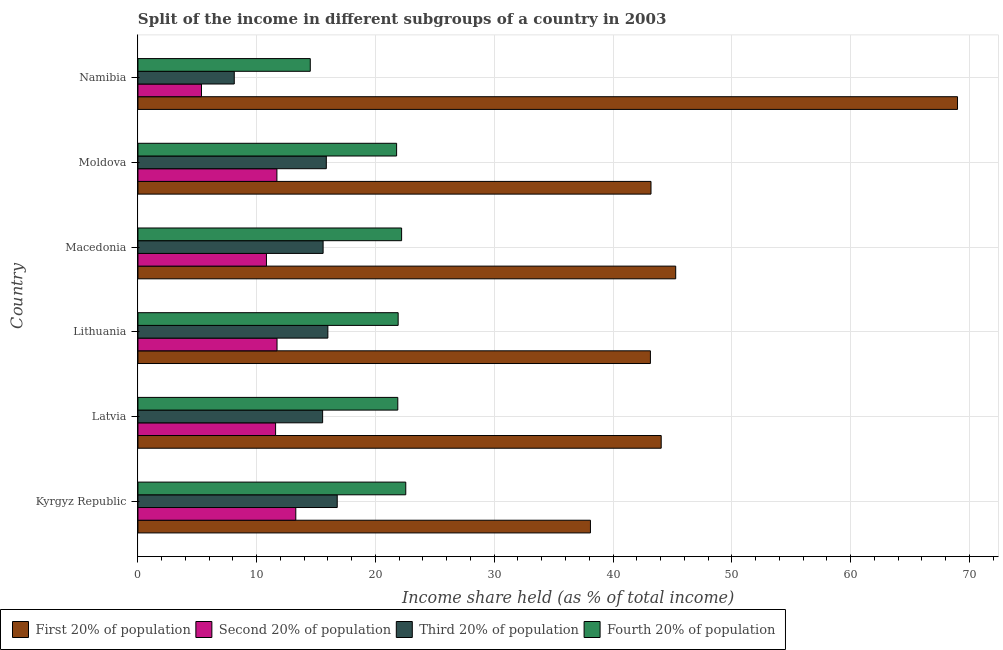How many groups of bars are there?
Provide a short and direct response. 6. What is the label of the 2nd group of bars from the top?
Your response must be concise. Moldova. What is the share of the income held by fourth 20% of the population in Namibia?
Make the answer very short. 14.51. Across all countries, what is the maximum share of the income held by fourth 20% of the population?
Offer a very short reply. 22.55. Across all countries, what is the minimum share of the income held by fourth 20% of the population?
Your answer should be compact. 14.51. In which country was the share of the income held by second 20% of the population maximum?
Make the answer very short. Kyrgyz Republic. In which country was the share of the income held by first 20% of the population minimum?
Give a very brief answer. Kyrgyz Republic. What is the total share of the income held by third 20% of the population in the graph?
Your response must be concise. 87.88. What is the difference between the share of the income held by second 20% of the population in Macedonia and that in Moldova?
Ensure brevity in your answer.  -0.88. What is the difference between the share of the income held by third 20% of the population in Kyrgyz Republic and the share of the income held by second 20% of the population in Lithuania?
Your answer should be compact. 5.07. What is the average share of the income held by first 20% of the population per country?
Offer a very short reply. 47.13. What is the difference between the share of the income held by third 20% of the population and share of the income held by fourth 20% of the population in Macedonia?
Give a very brief answer. -6.61. What is the ratio of the share of the income held by first 20% of the population in Kyrgyz Republic to that in Lithuania?
Make the answer very short. 0.88. What is the difference between the highest and the second highest share of the income held by first 20% of the population?
Provide a short and direct response. 23.73. What is the difference between the highest and the lowest share of the income held by first 20% of the population?
Your answer should be very brief. 30.91. Is the sum of the share of the income held by fourth 20% of the population in Latvia and Lithuania greater than the maximum share of the income held by third 20% of the population across all countries?
Your answer should be very brief. Yes. What does the 3rd bar from the top in Moldova represents?
Your answer should be very brief. Second 20% of population. What does the 3rd bar from the bottom in Namibia represents?
Provide a short and direct response. Third 20% of population. Is it the case that in every country, the sum of the share of the income held by first 20% of the population and share of the income held by second 20% of the population is greater than the share of the income held by third 20% of the population?
Ensure brevity in your answer.  Yes. How many bars are there?
Your answer should be very brief. 24. Are all the bars in the graph horizontal?
Your response must be concise. Yes. What is the difference between two consecutive major ticks on the X-axis?
Provide a succinct answer. 10. Are the values on the major ticks of X-axis written in scientific E-notation?
Provide a succinct answer. No. How many legend labels are there?
Your answer should be compact. 4. How are the legend labels stacked?
Give a very brief answer. Horizontal. What is the title of the graph?
Provide a short and direct response. Split of the income in different subgroups of a country in 2003. Does "First 20% of population" appear as one of the legend labels in the graph?
Your response must be concise. Yes. What is the label or title of the X-axis?
Provide a short and direct response. Income share held (as % of total income). What is the label or title of the Y-axis?
Keep it short and to the point. Country. What is the Income share held (as % of total income) in First 20% of population in Kyrgyz Republic?
Offer a terse response. 38.1. What is the Income share held (as % of total income) of Second 20% of population in Kyrgyz Republic?
Make the answer very short. 13.29. What is the Income share held (as % of total income) of Third 20% of population in Kyrgyz Republic?
Keep it short and to the point. 16.78. What is the Income share held (as % of total income) of Fourth 20% of population in Kyrgyz Republic?
Keep it short and to the point. 22.55. What is the Income share held (as % of total income) in First 20% of population in Latvia?
Your response must be concise. 44.06. What is the Income share held (as % of total income) of Second 20% of population in Latvia?
Ensure brevity in your answer.  11.59. What is the Income share held (as % of total income) in Third 20% of population in Latvia?
Offer a terse response. 15.55. What is the Income share held (as % of total income) of Fourth 20% of population in Latvia?
Ensure brevity in your answer.  21.88. What is the Income share held (as % of total income) in First 20% of population in Lithuania?
Offer a very short reply. 43.15. What is the Income share held (as % of total income) in Second 20% of population in Lithuania?
Offer a terse response. 11.71. What is the Income share held (as % of total income) of Third 20% of population in Lithuania?
Give a very brief answer. 15.99. What is the Income share held (as % of total income) of Fourth 20% of population in Lithuania?
Provide a succinct answer. 21.91. What is the Income share held (as % of total income) in First 20% of population in Macedonia?
Give a very brief answer. 45.28. What is the Income share held (as % of total income) of Second 20% of population in Macedonia?
Ensure brevity in your answer.  10.82. What is the Income share held (as % of total income) in Third 20% of population in Macedonia?
Your answer should be very brief. 15.59. What is the Income share held (as % of total income) of First 20% of population in Moldova?
Keep it short and to the point. 43.2. What is the Income share held (as % of total income) in Third 20% of population in Moldova?
Provide a short and direct response. 15.86. What is the Income share held (as % of total income) of Fourth 20% of population in Moldova?
Offer a very short reply. 21.78. What is the Income share held (as % of total income) in First 20% of population in Namibia?
Give a very brief answer. 69.01. What is the Income share held (as % of total income) of Second 20% of population in Namibia?
Give a very brief answer. 5.35. What is the Income share held (as % of total income) in Third 20% of population in Namibia?
Your answer should be compact. 8.11. What is the Income share held (as % of total income) in Fourth 20% of population in Namibia?
Your answer should be compact. 14.51. Across all countries, what is the maximum Income share held (as % of total income) in First 20% of population?
Make the answer very short. 69.01. Across all countries, what is the maximum Income share held (as % of total income) in Second 20% of population?
Give a very brief answer. 13.29. Across all countries, what is the maximum Income share held (as % of total income) of Third 20% of population?
Give a very brief answer. 16.78. Across all countries, what is the maximum Income share held (as % of total income) in Fourth 20% of population?
Your response must be concise. 22.55. Across all countries, what is the minimum Income share held (as % of total income) of First 20% of population?
Provide a succinct answer. 38.1. Across all countries, what is the minimum Income share held (as % of total income) of Second 20% of population?
Your answer should be compact. 5.35. Across all countries, what is the minimum Income share held (as % of total income) in Third 20% of population?
Offer a terse response. 8.11. Across all countries, what is the minimum Income share held (as % of total income) in Fourth 20% of population?
Provide a succinct answer. 14.51. What is the total Income share held (as % of total income) of First 20% of population in the graph?
Your answer should be compact. 282.8. What is the total Income share held (as % of total income) in Second 20% of population in the graph?
Your answer should be compact. 64.46. What is the total Income share held (as % of total income) in Third 20% of population in the graph?
Your answer should be very brief. 87.88. What is the total Income share held (as % of total income) of Fourth 20% of population in the graph?
Offer a terse response. 124.83. What is the difference between the Income share held (as % of total income) in First 20% of population in Kyrgyz Republic and that in Latvia?
Offer a very short reply. -5.96. What is the difference between the Income share held (as % of total income) in Second 20% of population in Kyrgyz Republic and that in Latvia?
Offer a terse response. 1.7. What is the difference between the Income share held (as % of total income) of Third 20% of population in Kyrgyz Republic and that in Latvia?
Your answer should be compact. 1.23. What is the difference between the Income share held (as % of total income) in Fourth 20% of population in Kyrgyz Republic and that in Latvia?
Offer a terse response. 0.67. What is the difference between the Income share held (as % of total income) in First 20% of population in Kyrgyz Republic and that in Lithuania?
Provide a short and direct response. -5.05. What is the difference between the Income share held (as % of total income) of Second 20% of population in Kyrgyz Republic and that in Lithuania?
Keep it short and to the point. 1.58. What is the difference between the Income share held (as % of total income) in Third 20% of population in Kyrgyz Republic and that in Lithuania?
Ensure brevity in your answer.  0.79. What is the difference between the Income share held (as % of total income) of Fourth 20% of population in Kyrgyz Republic and that in Lithuania?
Make the answer very short. 0.64. What is the difference between the Income share held (as % of total income) in First 20% of population in Kyrgyz Republic and that in Macedonia?
Provide a short and direct response. -7.18. What is the difference between the Income share held (as % of total income) of Second 20% of population in Kyrgyz Republic and that in Macedonia?
Give a very brief answer. 2.47. What is the difference between the Income share held (as % of total income) in Third 20% of population in Kyrgyz Republic and that in Macedonia?
Keep it short and to the point. 1.19. What is the difference between the Income share held (as % of total income) in First 20% of population in Kyrgyz Republic and that in Moldova?
Provide a short and direct response. -5.1. What is the difference between the Income share held (as % of total income) in Second 20% of population in Kyrgyz Republic and that in Moldova?
Your response must be concise. 1.59. What is the difference between the Income share held (as % of total income) of Third 20% of population in Kyrgyz Republic and that in Moldova?
Keep it short and to the point. 0.92. What is the difference between the Income share held (as % of total income) in Fourth 20% of population in Kyrgyz Republic and that in Moldova?
Ensure brevity in your answer.  0.77. What is the difference between the Income share held (as % of total income) of First 20% of population in Kyrgyz Republic and that in Namibia?
Your response must be concise. -30.91. What is the difference between the Income share held (as % of total income) of Second 20% of population in Kyrgyz Republic and that in Namibia?
Provide a short and direct response. 7.94. What is the difference between the Income share held (as % of total income) in Third 20% of population in Kyrgyz Republic and that in Namibia?
Ensure brevity in your answer.  8.67. What is the difference between the Income share held (as % of total income) of Fourth 20% of population in Kyrgyz Republic and that in Namibia?
Your answer should be very brief. 8.04. What is the difference between the Income share held (as % of total income) of First 20% of population in Latvia and that in Lithuania?
Your answer should be very brief. 0.91. What is the difference between the Income share held (as % of total income) of Second 20% of population in Latvia and that in Lithuania?
Provide a short and direct response. -0.12. What is the difference between the Income share held (as % of total income) of Third 20% of population in Latvia and that in Lithuania?
Your response must be concise. -0.44. What is the difference between the Income share held (as % of total income) of Fourth 20% of population in Latvia and that in Lithuania?
Give a very brief answer. -0.03. What is the difference between the Income share held (as % of total income) of First 20% of population in Latvia and that in Macedonia?
Provide a short and direct response. -1.22. What is the difference between the Income share held (as % of total income) in Second 20% of population in Latvia and that in Macedonia?
Your answer should be very brief. 0.77. What is the difference between the Income share held (as % of total income) of Third 20% of population in Latvia and that in Macedonia?
Your answer should be compact. -0.04. What is the difference between the Income share held (as % of total income) in Fourth 20% of population in Latvia and that in Macedonia?
Keep it short and to the point. -0.32. What is the difference between the Income share held (as % of total income) of First 20% of population in Latvia and that in Moldova?
Your answer should be very brief. 0.86. What is the difference between the Income share held (as % of total income) in Second 20% of population in Latvia and that in Moldova?
Ensure brevity in your answer.  -0.11. What is the difference between the Income share held (as % of total income) of Third 20% of population in Latvia and that in Moldova?
Provide a short and direct response. -0.31. What is the difference between the Income share held (as % of total income) in Fourth 20% of population in Latvia and that in Moldova?
Keep it short and to the point. 0.1. What is the difference between the Income share held (as % of total income) of First 20% of population in Latvia and that in Namibia?
Offer a very short reply. -24.95. What is the difference between the Income share held (as % of total income) of Second 20% of population in Latvia and that in Namibia?
Offer a terse response. 6.24. What is the difference between the Income share held (as % of total income) of Third 20% of population in Latvia and that in Namibia?
Provide a short and direct response. 7.44. What is the difference between the Income share held (as % of total income) of Fourth 20% of population in Latvia and that in Namibia?
Make the answer very short. 7.37. What is the difference between the Income share held (as % of total income) of First 20% of population in Lithuania and that in Macedonia?
Provide a succinct answer. -2.13. What is the difference between the Income share held (as % of total income) of Second 20% of population in Lithuania and that in Macedonia?
Keep it short and to the point. 0.89. What is the difference between the Income share held (as % of total income) of Third 20% of population in Lithuania and that in Macedonia?
Provide a short and direct response. 0.4. What is the difference between the Income share held (as % of total income) in Fourth 20% of population in Lithuania and that in Macedonia?
Provide a succinct answer. -0.29. What is the difference between the Income share held (as % of total income) in First 20% of population in Lithuania and that in Moldova?
Your answer should be very brief. -0.05. What is the difference between the Income share held (as % of total income) of Second 20% of population in Lithuania and that in Moldova?
Provide a short and direct response. 0.01. What is the difference between the Income share held (as % of total income) of Third 20% of population in Lithuania and that in Moldova?
Provide a succinct answer. 0.13. What is the difference between the Income share held (as % of total income) of Fourth 20% of population in Lithuania and that in Moldova?
Your response must be concise. 0.13. What is the difference between the Income share held (as % of total income) of First 20% of population in Lithuania and that in Namibia?
Offer a terse response. -25.86. What is the difference between the Income share held (as % of total income) of Second 20% of population in Lithuania and that in Namibia?
Offer a very short reply. 6.36. What is the difference between the Income share held (as % of total income) in Third 20% of population in Lithuania and that in Namibia?
Provide a succinct answer. 7.88. What is the difference between the Income share held (as % of total income) in First 20% of population in Macedonia and that in Moldova?
Keep it short and to the point. 2.08. What is the difference between the Income share held (as % of total income) in Second 20% of population in Macedonia and that in Moldova?
Ensure brevity in your answer.  -0.88. What is the difference between the Income share held (as % of total income) in Third 20% of population in Macedonia and that in Moldova?
Provide a succinct answer. -0.27. What is the difference between the Income share held (as % of total income) in Fourth 20% of population in Macedonia and that in Moldova?
Your answer should be compact. 0.42. What is the difference between the Income share held (as % of total income) in First 20% of population in Macedonia and that in Namibia?
Ensure brevity in your answer.  -23.73. What is the difference between the Income share held (as % of total income) of Second 20% of population in Macedonia and that in Namibia?
Offer a terse response. 5.47. What is the difference between the Income share held (as % of total income) of Third 20% of population in Macedonia and that in Namibia?
Provide a short and direct response. 7.48. What is the difference between the Income share held (as % of total income) of Fourth 20% of population in Macedonia and that in Namibia?
Give a very brief answer. 7.69. What is the difference between the Income share held (as % of total income) of First 20% of population in Moldova and that in Namibia?
Offer a terse response. -25.81. What is the difference between the Income share held (as % of total income) in Second 20% of population in Moldova and that in Namibia?
Ensure brevity in your answer.  6.35. What is the difference between the Income share held (as % of total income) of Third 20% of population in Moldova and that in Namibia?
Give a very brief answer. 7.75. What is the difference between the Income share held (as % of total income) of Fourth 20% of population in Moldova and that in Namibia?
Give a very brief answer. 7.27. What is the difference between the Income share held (as % of total income) of First 20% of population in Kyrgyz Republic and the Income share held (as % of total income) of Second 20% of population in Latvia?
Make the answer very short. 26.51. What is the difference between the Income share held (as % of total income) in First 20% of population in Kyrgyz Republic and the Income share held (as % of total income) in Third 20% of population in Latvia?
Ensure brevity in your answer.  22.55. What is the difference between the Income share held (as % of total income) of First 20% of population in Kyrgyz Republic and the Income share held (as % of total income) of Fourth 20% of population in Latvia?
Keep it short and to the point. 16.22. What is the difference between the Income share held (as % of total income) in Second 20% of population in Kyrgyz Republic and the Income share held (as % of total income) in Third 20% of population in Latvia?
Your response must be concise. -2.26. What is the difference between the Income share held (as % of total income) in Second 20% of population in Kyrgyz Republic and the Income share held (as % of total income) in Fourth 20% of population in Latvia?
Your response must be concise. -8.59. What is the difference between the Income share held (as % of total income) in First 20% of population in Kyrgyz Republic and the Income share held (as % of total income) in Second 20% of population in Lithuania?
Make the answer very short. 26.39. What is the difference between the Income share held (as % of total income) of First 20% of population in Kyrgyz Republic and the Income share held (as % of total income) of Third 20% of population in Lithuania?
Your answer should be very brief. 22.11. What is the difference between the Income share held (as % of total income) of First 20% of population in Kyrgyz Republic and the Income share held (as % of total income) of Fourth 20% of population in Lithuania?
Offer a very short reply. 16.19. What is the difference between the Income share held (as % of total income) of Second 20% of population in Kyrgyz Republic and the Income share held (as % of total income) of Third 20% of population in Lithuania?
Your answer should be compact. -2.7. What is the difference between the Income share held (as % of total income) of Second 20% of population in Kyrgyz Republic and the Income share held (as % of total income) of Fourth 20% of population in Lithuania?
Provide a succinct answer. -8.62. What is the difference between the Income share held (as % of total income) of Third 20% of population in Kyrgyz Republic and the Income share held (as % of total income) of Fourth 20% of population in Lithuania?
Make the answer very short. -5.13. What is the difference between the Income share held (as % of total income) of First 20% of population in Kyrgyz Republic and the Income share held (as % of total income) of Second 20% of population in Macedonia?
Provide a short and direct response. 27.28. What is the difference between the Income share held (as % of total income) in First 20% of population in Kyrgyz Republic and the Income share held (as % of total income) in Third 20% of population in Macedonia?
Your answer should be compact. 22.51. What is the difference between the Income share held (as % of total income) in Second 20% of population in Kyrgyz Republic and the Income share held (as % of total income) in Fourth 20% of population in Macedonia?
Provide a short and direct response. -8.91. What is the difference between the Income share held (as % of total income) of Third 20% of population in Kyrgyz Republic and the Income share held (as % of total income) of Fourth 20% of population in Macedonia?
Offer a very short reply. -5.42. What is the difference between the Income share held (as % of total income) in First 20% of population in Kyrgyz Republic and the Income share held (as % of total income) in Second 20% of population in Moldova?
Provide a short and direct response. 26.4. What is the difference between the Income share held (as % of total income) in First 20% of population in Kyrgyz Republic and the Income share held (as % of total income) in Third 20% of population in Moldova?
Keep it short and to the point. 22.24. What is the difference between the Income share held (as % of total income) of First 20% of population in Kyrgyz Republic and the Income share held (as % of total income) of Fourth 20% of population in Moldova?
Your answer should be compact. 16.32. What is the difference between the Income share held (as % of total income) in Second 20% of population in Kyrgyz Republic and the Income share held (as % of total income) in Third 20% of population in Moldova?
Keep it short and to the point. -2.57. What is the difference between the Income share held (as % of total income) of Second 20% of population in Kyrgyz Republic and the Income share held (as % of total income) of Fourth 20% of population in Moldova?
Make the answer very short. -8.49. What is the difference between the Income share held (as % of total income) in First 20% of population in Kyrgyz Republic and the Income share held (as % of total income) in Second 20% of population in Namibia?
Provide a short and direct response. 32.75. What is the difference between the Income share held (as % of total income) in First 20% of population in Kyrgyz Republic and the Income share held (as % of total income) in Third 20% of population in Namibia?
Ensure brevity in your answer.  29.99. What is the difference between the Income share held (as % of total income) in First 20% of population in Kyrgyz Republic and the Income share held (as % of total income) in Fourth 20% of population in Namibia?
Ensure brevity in your answer.  23.59. What is the difference between the Income share held (as % of total income) in Second 20% of population in Kyrgyz Republic and the Income share held (as % of total income) in Third 20% of population in Namibia?
Your answer should be compact. 5.18. What is the difference between the Income share held (as % of total income) of Second 20% of population in Kyrgyz Republic and the Income share held (as % of total income) of Fourth 20% of population in Namibia?
Your response must be concise. -1.22. What is the difference between the Income share held (as % of total income) in Third 20% of population in Kyrgyz Republic and the Income share held (as % of total income) in Fourth 20% of population in Namibia?
Your response must be concise. 2.27. What is the difference between the Income share held (as % of total income) of First 20% of population in Latvia and the Income share held (as % of total income) of Second 20% of population in Lithuania?
Offer a very short reply. 32.35. What is the difference between the Income share held (as % of total income) in First 20% of population in Latvia and the Income share held (as % of total income) in Third 20% of population in Lithuania?
Your response must be concise. 28.07. What is the difference between the Income share held (as % of total income) of First 20% of population in Latvia and the Income share held (as % of total income) of Fourth 20% of population in Lithuania?
Provide a short and direct response. 22.15. What is the difference between the Income share held (as % of total income) in Second 20% of population in Latvia and the Income share held (as % of total income) in Third 20% of population in Lithuania?
Provide a short and direct response. -4.4. What is the difference between the Income share held (as % of total income) in Second 20% of population in Latvia and the Income share held (as % of total income) in Fourth 20% of population in Lithuania?
Offer a terse response. -10.32. What is the difference between the Income share held (as % of total income) in Third 20% of population in Latvia and the Income share held (as % of total income) in Fourth 20% of population in Lithuania?
Provide a short and direct response. -6.36. What is the difference between the Income share held (as % of total income) of First 20% of population in Latvia and the Income share held (as % of total income) of Second 20% of population in Macedonia?
Ensure brevity in your answer.  33.24. What is the difference between the Income share held (as % of total income) of First 20% of population in Latvia and the Income share held (as % of total income) of Third 20% of population in Macedonia?
Your answer should be compact. 28.47. What is the difference between the Income share held (as % of total income) in First 20% of population in Latvia and the Income share held (as % of total income) in Fourth 20% of population in Macedonia?
Offer a very short reply. 21.86. What is the difference between the Income share held (as % of total income) in Second 20% of population in Latvia and the Income share held (as % of total income) in Third 20% of population in Macedonia?
Make the answer very short. -4. What is the difference between the Income share held (as % of total income) of Second 20% of population in Latvia and the Income share held (as % of total income) of Fourth 20% of population in Macedonia?
Ensure brevity in your answer.  -10.61. What is the difference between the Income share held (as % of total income) of Third 20% of population in Latvia and the Income share held (as % of total income) of Fourth 20% of population in Macedonia?
Offer a terse response. -6.65. What is the difference between the Income share held (as % of total income) of First 20% of population in Latvia and the Income share held (as % of total income) of Second 20% of population in Moldova?
Your answer should be compact. 32.36. What is the difference between the Income share held (as % of total income) of First 20% of population in Latvia and the Income share held (as % of total income) of Third 20% of population in Moldova?
Ensure brevity in your answer.  28.2. What is the difference between the Income share held (as % of total income) in First 20% of population in Latvia and the Income share held (as % of total income) in Fourth 20% of population in Moldova?
Ensure brevity in your answer.  22.28. What is the difference between the Income share held (as % of total income) in Second 20% of population in Latvia and the Income share held (as % of total income) in Third 20% of population in Moldova?
Ensure brevity in your answer.  -4.27. What is the difference between the Income share held (as % of total income) of Second 20% of population in Latvia and the Income share held (as % of total income) of Fourth 20% of population in Moldova?
Provide a short and direct response. -10.19. What is the difference between the Income share held (as % of total income) of Third 20% of population in Latvia and the Income share held (as % of total income) of Fourth 20% of population in Moldova?
Offer a terse response. -6.23. What is the difference between the Income share held (as % of total income) in First 20% of population in Latvia and the Income share held (as % of total income) in Second 20% of population in Namibia?
Keep it short and to the point. 38.71. What is the difference between the Income share held (as % of total income) in First 20% of population in Latvia and the Income share held (as % of total income) in Third 20% of population in Namibia?
Offer a very short reply. 35.95. What is the difference between the Income share held (as % of total income) in First 20% of population in Latvia and the Income share held (as % of total income) in Fourth 20% of population in Namibia?
Provide a short and direct response. 29.55. What is the difference between the Income share held (as % of total income) in Second 20% of population in Latvia and the Income share held (as % of total income) in Third 20% of population in Namibia?
Offer a very short reply. 3.48. What is the difference between the Income share held (as % of total income) in Second 20% of population in Latvia and the Income share held (as % of total income) in Fourth 20% of population in Namibia?
Offer a terse response. -2.92. What is the difference between the Income share held (as % of total income) in First 20% of population in Lithuania and the Income share held (as % of total income) in Second 20% of population in Macedonia?
Offer a very short reply. 32.33. What is the difference between the Income share held (as % of total income) in First 20% of population in Lithuania and the Income share held (as % of total income) in Third 20% of population in Macedonia?
Make the answer very short. 27.56. What is the difference between the Income share held (as % of total income) of First 20% of population in Lithuania and the Income share held (as % of total income) of Fourth 20% of population in Macedonia?
Your answer should be very brief. 20.95. What is the difference between the Income share held (as % of total income) in Second 20% of population in Lithuania and the Income share held (as % of total income) in Third 20% of population in Macedonia?
Offer a very short reply. -3.88. What is the difference between the Income share held (as % of total income) of Second 20% of population in Lithuania and the Income share held (as % of total income) of Fourth 20% of population in Macedonia?
Provide a short and direct response. -10.49. What is the difference between the Income share held (as % of total income) of Third 20% of population in Lithuania and the Income share held (as % of total income) of Fourth 20% of population in Macedonia?
Your answer should be very brief. -6.21. What is the difference between the Income share held (as % of total income) of First 20% of population in Lithuania and the Income share held (as % of total income) of Second 20% of population in Moldova?
Ensure brevity in your answer.  31.45. What is the difference between the Income share held (as % of total income) in First 20% of population in Lithuania and the Income share held (as % of total income) in Third 20% of population in Moldova?
Your response must be concise. 27.29. What is the difference between the Income share held (as % of total income) of First 20% of population in Lithuania and the Income share held (as % of total income) of Fourth 20% of population in Moldova?
Keep it short and to the point. 21.37. What is the difference between the Income share held (as % of total income) in Second 20% of population in Lithuania and the Income share held (as % of total income) in Third 20% of population in Moldova?
Keep it short and to the point. -4.15. What is the difference between the Income share held (as % of total income) of Second 20% of population in Lithuania and the Income share held (as % of total income) of Fourth 20% of population in Moldova?
Offer a very short reply. -10.07. What is the difference between the Income share held (as % of total income) of Third 20% of population in Lithuania and the Income share held (as % of total income) of Fourth 20% of population in Moldova?
Provide a succinct answer. -5.79. What is the difference between the Income share held (as % of total income) of First 20% of population in Lithuania and the Income share held (as % of total income) of Second 20% of population in Namibia?
Make the answer very short. 37.8. What is the difference between the Income share held (as % of total income) in First 20% of population in Lithuania and the Income share held (as % of total income) in Third 20% of population in Namibia?
Provide a short and direct response. 35.04. What is the difference between the Income share held (as % of total income) of First 20% of population in Lithuania and the Income share held (as % of total income) of Fourth 20% of population in Namibia?
Provide a succinct answer. 28.64. What is the difference between the Income share held (as % of total income) in Third 20% of population in Lithuania and the Income share held (as % of total income) in Fourth 20% of population in Namibia?
Ensure brevity in your answer.  1.48. What is the difference between the Income share held (as % of total income) in First 20% of population in Macedonia and the Income share held (as % of total income) in Second 20% of population in Moldova?
Keep it short and to the point. 33.58. What is the difference between the Income share held (as % of total income) of First 20% of population in Macedonia and the Income share held (as % of total income) of Third 20% of population in Moldova?
Your answer should be compact. 29.42. What is the difference between the Income share held (as % of total income) in First 20% of population in Macedonia and the Income share held (as % of total income) in Fourth 20% of population in Moldova?
Provide a succinct answer. 23.5. What is the difference between the Income share held (as % of total income) of Second 20% of population in Macedonia and the Income share held (as % of total income) of Third 20% of population in Moldova?
Give a very brief answer. -5.04. What is the difference between the Income share held (as % of total income) of Second 20% of population in Macedonia and the Income share held (as % of total income) of Fourth 20% of population in Moldova?
Ensure brevity in your answer.  -10.96. What is the difference between the Income share held (as % of total income) of Third 20% of population in Macedonia and the Income share held (as % of total income) of Fourth 20% of population in Moldova?
Ensure brevity in your answer.  -6.19. What is the difference between the Income share held (as % of total income) of First 20% of population in Macedonia and the Income share held (as % of total income) of Second 20% of population in Namibia?
Keep it short and to the point. 39.93. What is the difference between the Income share held (as % of total income) in First 20% of population in Macedonia and the Income share held (as % of total income) in Third 20% of population in Namibia?
Keep it short and to the point. 37.17. What is the difference between the Income share held (as % of total income) of First 20% of population in Macedonia and the Income share held (as % of total income) of Fourth 20% of population in Namibia?
Provide a succinct answer. 30.77. What is the difference between the Income share held (as % of total income) in Second 20% of population in Macedonia and the Income share held (as % of total income) in Third 20% of population in Namibia?
Make the answer very short. 2.71. What is the difference between the Income share held (as % of total income) in Second 20% of population in Macedonia and the Income share held (as % of total income) in Fourth 20% of population in Namibia?
Offer a terse response. -3.69. What is the difference between the Income share held (as % of total income) of First 20% of population in Moldova and the Income share held (as % of total income) of Second 20% of population in Namibia?
Keep it short and to the point. 37.85. What is the difference between the Income share held (as % of total income) of First 20% of population in Moldova and the Income share held (as % of total income) of Third 20% of population in Namibia?
Give a very brief answer. 35.09. What is the difference between the Income share held (as % of total income) in First 20% of population in Moldova and the Income share held (as % of total income) in Fourth 20% of population in Namibia?
Give a very brief answer. 28.69. What is the difference between the Income share held (as % of total income) of Second 20% of population in Moldova and the Income share held (as % of total income) of Third 20% of population in Namibia?
Give a very brief answer. 3.59. What is the difference between the Income share held (as % of total income) of Second 20% of population in Moldova and the Income share held (as % of total income) of Fourth 20% of population in Namibia?
Your response must be concise. -2.81. What is the difference between the Income share held (as % of total income) of Third 20% of population in Moldova and the Income share held (as % of total income) of Fourth 20% of population in Namibia?
Make the answer very short. 1.35. What is the average Income share held (as % of total income) of First 20% of population per country?
Keep it short and to the point. 47.13. What is the average Income share held (as % of total income) in Second 20% of population per country?
Your answer should be very brief. 10.74. What is the average Income share held (as % of total income) in Third 20% of population per country?
Provide a succinct answer. 14.65. What is the average Income share held (as % of total income) of Fourth 20% of population per country?
Offer a very short reply. 20.8. What is the difference between the Income share held (as % of total income) of First 20% of population and Income share held (as % of total income) of Second 20% of population in Kyrgyz Republic?
Provide a short and direct response. 24.81. What is the difference between the Income share held (as % of total income) of First 20% of population and Income share held (as % of total income) of Third 20% of population in Kyrgyz Republic?
Your answer should be very brief. 21.32. What is the difference between the Income share held (as % of total income) of First 20% of population and Income share held (as % of total income) of Fourth 20% of population in Kyrgyz Republic?
Your answer should be very brief. 15.55. What is the difference between the Income share held (as % of total income) in Second 20% of population and Income share held (as % of total income) in Third 20% of population in Kyrgyz Republic?
Give a very brief answer. -3.49. What is the difference between the Income share held (as % of total income) in Second 20% of population and Income share held (as % of total income) in Fourth 20% of population in Kyrgyz Republic?
Your answer should be compact. -9.26. What is the difference between the Income share held (as % of total income) in Third 20% of population and Income share held (as % of total income) in Fourth 20% of population in Kyrgyz Republic?
Give a very brief answer. -5.77. What is the difference between the Income share held (as % of total income) of First 20% of population and Income share held (as % of total income) of Second 20% of population in Latvia?
Your answer should be very brief. 32.47. What is the difference between the Income share held (as % of total income) in First 20% of population and Income share held (as % of total income) in Third 20% of population in Latvia?
Offer a terse response. 28.51. What is the difference between the Income share held (as % of total income) in First 20% of population and Income share held (as % of total income) in Fourth 20% of population in Latvia?
Your answer should be very brief. 22.18. What is the difference between the Income share held (as % of total income) of Second 20% of population and Income share held (as % of total income) of Third 20% of population in Latvia?
Ensure brevity in your answer.  -3.96. What is the difference between the Income share held (as % of total income) of Second 20% of population and Income share held (as % of total income) of Fourth 20% of population in Latvia?
Your answer should be very brief. -10.29. What is the difference between the Income share held (as % of total income) in Third 20% of population and Income share held (as % of total income) in Fourth 20% of population in Latvia?
Provide a short and direct response. -6.33. What is the difference between the Income share held (as % of total income) of First 20% of population and Income share held (as % of total income) of Second 20% of population in Lithuania?
Provide a short and direct response. 31.44. What is the difference between the Income share held (as % of total income) in First 20% of population and Income share held (as % of total income) in Third 20% of population in Lithuania?
Your answer should be very brief. 27.16. What is the difference between the Income share held (as % of total income) in First 20% of population and Income share held (as % of total income) in Fourth 20% of population in Lithuania?
Give a very brief answer. 21.24. What is the difference between the Income share held (as % of total income) in Second 20% of population and Income share held (as % of total income) in Third 20% of population in Lithuania?
Ensure brevity in your answer.  -4.28. What is the difference between the Income share held (as % of total income) in Second 20% of population and Income share held (as % of total income) in Fourth 20% of population in Lithuania?
Offer a very short reply. -10.2. What is the difference between the Income share held (as % of total income) of Third 20% of population and Income share held (as % of total income) of Fourth 20% of population in Lithuania?
Your response must be concise. -5.92. What is the difference between the Income share held (as % of total income) in First 20% of population and Income share held (as % of total income) in Second 20% of population in Macedonia?
Ensure brevity in your answer.  34.46. What is the difference between the Income share held (as % of total income) in First 20% of population and Income share held (as % of total income) in Third 20% of population in Macedonia?
Your answer should be compact. 29.69. What is the difference between the Income share held (as % of total income) in First 20% of population and Income share held (as % of total income) in Fourth 20% of population in Macedonia?
Ensure brevity in your answer.  23.08. What is the difference between the Income share held (as % of total income) of Second 20% of population and Income share held (as % of total income) of Third 20% of population in Macedonia?
Provide a succinct answer. -4.77. What is the difference between the Income share held (as % of total income) of Second 20% of population and Income share held (as % of total income) of Fourth 20% of population in Macedonia?
Offer a very short reply. -11.38. What is the difference between the Income share held (as % of total income) in Third 20% of population and Income share held (as % of total income) in Fourth 20% of population in Macedonia?
Provide a short and direct response. -6.61. What is the difference between the Income share held (as % of total income) in First 20% of population and Income share held (as % of total income) in Second 20% of population in Moldova?
Provide a succinct answer. 31.5. What is the difference between the Income share held (as % of total income) in First 20% of population and Income share held (as % of total income) in Third 20% of population in Moldova?
Your answer should be compact. 27.34. What is the difference between the Income share held (as % of total income) in First 20% of population and Income share held (as % of total income) in Fourth 20% of population in Moldova?
Give a very brief answer. 21.42. What is the difference between the Income share held (as % of total income) in Second 20% of population and Income share held (as % of total income) in Third 20% of population in Moldova?
Make the answer very short. -4.16. What is the difference between the Income share held (as % of total income) of Second 20% of population and Income share held (as % of total income) of Fourth 20% of population in Moldova?
Make the answer very short. -10.08. What is the difference between the Income share held (as % of total income) of Third 20% of population and Income share held (as % of total income) of Fourth 20% of population in Moldova?
Your response must be concise. -5.92. What is the difference between the Income share held (as % of total income) in First 20% of population and Income share held (as % of total income) in Second 20% of population in Namibia?
Ensure brevity in your answer.  63.66. What is the difference between the Income share held (as % of total income) of First 20% of population and Income share held (as % of total income) of Third 20% of population in Namibia?
Ensure brevity in your answer.  60.9. What is the difference between the Income share held (as % of total income) in First 20% of population and Income share held (as % of total income) in Fourth 20% of population in Namibia?
Give a very brief answer. 54.5. What is the difference between the Income share held (as % of total income) in Second 20% of population and Income share held (as % of total income) in Third 20% of population in Namibia?
Offer a terse response. -2.76. What is the difference between the Income share held (as % of total income) in Second 20% of population and Income share held (as % of total income) in Fourth 20% of population in Namibia?
Provide a succinct answer. -9.16. What is the difference between the Income share held (as % of total income) of Third 20% of population and Income share held (as % of total income) of Fourth 20% of population in Namibia?
Offer a very short reply. -6.4. What is the ratio of the Income share held (as % of total income) in First 20% of population in Kyrgyz Republic to that in Latvia?
Keep it short and to the point. 0.86. What is the ratio of the Income share held (as % of total income) of Second 20% of population in Kyrgyz Republic to that in Latvia?
Your answer should be very brief. 1.15. What is the ratio of the Income share held (as % of total income) of Third 20% of population in Kyrgyz Republic to that in Latvia?
Offer a very short reply. 1.08. What is the ratio of the Income share held (as % of total income) of Fourth 20% of population in Kyrgyz Republic to that in Latvia?
Ensure brevity in your answer.  1.03. What is the ratio of the Income share held (as % of total income) of First 20% of population in Kyrgyz Republic to that in Lithuania?
Give a very brief answer. 0.88. What is the ratio of the Income share held (as % of total income) of Second 20% of population in Kyrgyz Republic to that in Lithuania?
Offer a terse response. 1.13. What is the ratio of the Income share held (as % of total income) in Third 20% of population in Kyrgyz Republic to that in Lithuania?
Offer a very short reply. 1.05. What is the ratio of the Income share held (as % of total income) in Fourth 20% of population in Kyrgyz Republic to that in Lithuania?
Offer a very short reply. 1.03. What is the ratio of the Income share held (as % of total income) in First 20% of population in Kyrgyz Republic to that in Macedonia?
Provide a short and direct response. 0.84. What is the ratio of the Income share held (as % of total income) in Second 20% of population in Kyrgyz Republic to that in Macedonia?
Provide a short and direct response. 1.23. What is the ratio of the Income share held (as % of total income) in Third 20% of population in Kyrgyz Republic to that in Macedonia?
Offer a very short reply. 1.08. What is the ratio of the Income share held (as % of total income) in Fourth 20% of population in Kyrgyz Republic to that in Macedonia?
Provide a short and direct response. 1.02. What is the ratio of the Income share held (as % of total income) of First 20% of population in Kyrgyz Republic to that in Moldova?
Your answer should be compact. 0.88. What is the ratio of the Income share held (as % of total income) in Second 20% of population in Kyrgyz Republic to that in Moldova?
Your response must be concise. 1.14. What is the ratio of the Income share held (as % of total income) of Third 20% of population in Kyrgyz Republic to that in Moldova?
Offer a very short reply. 1.06. What is the ratio of the Income share held (as % of total income) of Fourth 20% of population in Kyrgyz Republic to that in Moldova?
Offer a terse response. 1.04. What is the ratio of the Income share held (as % of total income) in First 20% of population in Kyrgyz Republic to that in Namibia?
Your response must be concise. 0.55. What is the ratio of the Income share held (as % of total income) in Second 20% of population in Kyrgyz Republic to that in Namibia?
Your answer should be compact. 2.48. What is the ratio of the Income share held (as % of total income) of Third 20% of population in Kyrgyz Republic to that in Namibia?
Your answer should be compact. 2.07. What is the ratio of the Income share held (as % of total income) in Fourth 20% of population in Kyrgyz Republic to that in Namibia?
Ensure brevity in your answer.  1.55. What is the ratio of the Income share held (as % of total income) in First 20% of population in Latvia to that in Lithuania?
Provide a short and direct response. 1.02. What is the ratio of the Income share held (as % of total income) in Second 20% of population in Latvia to that in Lithuania?
Provide a short and direct response. 0.99. What is the ratio of the Income share held (as % of total income) of Third 20% of population in Latvia to that in Lithuania?
Offer a terse response. 0.97. What is the ratio of the Income share held (as % of total income) of First 20% of population in Latvia to that in Macedonia?
Your answer should be compact. 0.97. What is the ratio of the Income share held (as % of total income) of Second 20% of population in Latvia to that in Macedonia?
Ensure brevity in your answer.  1.07. What is the ratio of the Income share held (as % of total income) in Third 20% of population in Latvia to that in Macedonia?
Provide a short and direct response. 1. What is the ratio of the Income share held (as % of total income) of Fourth 20% of population in Latvia to that in Macedonia?
Keep it short and to the point. 0.99. What is the ratio of the Income share held (as % of total income) in First 20% of population in Latvia to that in Moldova?
Offer a terse response. 1.02. What is the ratio of the Income share held (as % of total income) of Second 20% of population in Latvia to that in Moldova?
Your answer should be compact. 0.99. What is the ratio of the Income share held (as % of total income) in Third 20% of population in Latvia to that in Moldova?
Keep it short and to the point. 0.98. What is the ratio of the Income share held (as % of total income) in Fourth 20% of population in Latvia to that in Moldova?
Your answer should be very brief. 1. What is the ratio of the Income share held (as % of total income) in First 20% of population in Latvia to that in Namibia?
Your answer should be very brief. 0.64. What is the ratio of the Income share held (as % of total income) of Second 20% of population in Latvia to that in Namibia?
Your answer should be very brief. 2.17. What is the ratio of the Income share held (as % of total income) of Third 20% of population in Latvia to that in Namibia?
Offer a very short reply. 1.92. What is the ratio of the Income share held (as % of total income) in Fourth 20% of population in Latvia to that in Namibia?
Keep it short and to the point. 1.51. What is the ratio of the Income share held (as % of total income) of First 20% of population in Lithuania to that in Macedonia?
Offer a very short reply. 0.95. What is the ratio of the Income share held (as % of total income) in Second 20% of population in Lithuania to that in Macedonia?
Provide a short and direct response. 1.08. What is the ratio of the Income share held (as % of total income) of Third 20% of population in Lithuania to that in Macedonia?
Your response must be concise. 1.03. What is the ratio of the Income share held (as % of total income) in Fourth 20% of population in Lithuania to that in Macedonia?
Make the answer very short. 0.99. What is the ratio of the Income share held (as % of total income) of First 20% of population in Lithuania to that in Moldova?
Give a very brief answer. 1. What is the ratio of the Income share held (as % of total income) in Third 20% of population in Lithuania to that in Moldova?
Provide a short and direct response. 1.01. What is the ratio of the Income share held (as % of total income) of Fourth 20% of population in Lithuania to that in Moldova?
Provide a succinct answer. 1.01. What is the ratio of the Income share held (as % of total income) of First 20% of population in Lithuania to that in Namibia?
Make the answer very short. 0.63. What is the ratio of the Income share held (as % of total income) in Second 20% of population in Lithuania to that in Namibia?
Ensure brevity in your answer.  2.19. What is the ratio of the Income share held (as % of total income) of Third 20% of population in Lithuania to that in Namibia?
Provide a succinct answer. 1.97. What is the ratio of the Income share held (as % of total income) in Fourth 20% of population in Lithuania to that in Namibia?
Make the answer very short. 1.51. What is the ratio of the Income share held (as % of total income) in First 20% of population in Macedonia to that in Moldova?
Your answer should be compact. 1.05. What is the ratio of the Income share held (as % of total income) of Second 20% of population in Macedonia to that in Moldova?
Give a very brief answer. 0.92. What is the ratio of the Income share held (as % of total income) of Fourth 20% of population in Macedonia to that in Moldova?
Provide a short and direct response. 1.02. What is the ratio of the Income share held (as % of total income) in First 20% of population in Macedonia to that in Namibia?
Make the answer very short. 0.66. What is the ratio of the Income share held (as % of total income) in Second 20% of population in Macedonia to that in Namibia?
Your answer should be very brief. 2.02. What is the ratio of the Income share held (as % of total income) of Third 20% of population in Macedonia to that in Namibia?
Your answer should be compact. 1.92. What is the ratio of the Income share held (as % of total income) of Fourth 20% of population in Macedonia to that in Namibia?
Give a very brief answer. 1.53. What is the ratio of the Income share held (as % of total income) in First 20% of population in Moldova to that in Namibia?
Give a very brief answer. 0.63. What is the ratio of the Income share held (as % of total income) of Second 20% of population in Moldova to that in Namibia?
Give a very brief answer. 2.19. What is the ratio of the Income share held (as % of total income) in Third 20% of population in Moldova to that in Namibia?
Your response must be concise. 1.96. What is the ratio of the Income share held (as % of total income) in Fourth 20% of population in Moldova to that in Namibia?
Keep it short and to the point. 1.5. What is the difference between the highest and the second highest Income share held (as % of total income) of First 20% of population?
Keep it short and to the point. 23.73. What is the difference between the highest and the second highest Income share held (as % of total income) in Second 20% of population?
Make the answer very short. 1.58. What is the difference between the highest and the second highest Income share held (as % of total income) of Third 20% of population?
Offer a terse response. 0.79. What is the difference between the highest and the lowest Income share held (as % of total income) of First 20% of population?
Give a very brief answer. 30.91. What is the difference between the highest and the lowest Income share held (as % of total income) in Second 20% of population?
Make the answer very short. 7.94. What is the difference between the highest and the lowest Income share held (as % of total income) of Third 20% of population?
Your answer should be compact. 8.67. What is the difference between the highest and the lowest Income share held (as % of total income) in Fourth 20% of population?
Keep it short and to the point. 8.04. 